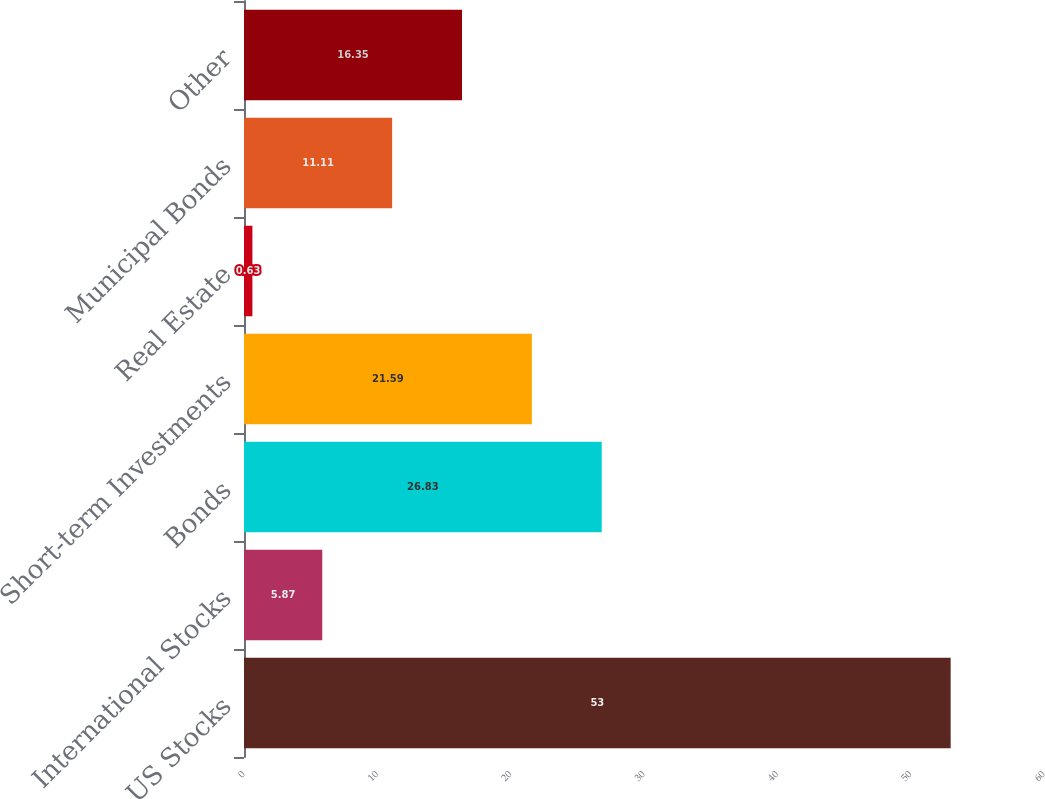Convert chart to OTSL. <chart><loc_0><loc_0><loc_500><loc_500><bar_chart><fcel>US Stocks<fcel>International Stocks<fcel>Bonds<fcel>Short-term Investments<fcel>Real Estate<fcel>Municipal Bonds<fcel>Other<nl><fcel>53<fcel>5.87<fcel>26.83<fcel>21.59<fcel>0.63<fcel>11.11<fcel>16.35<nl></chart> 